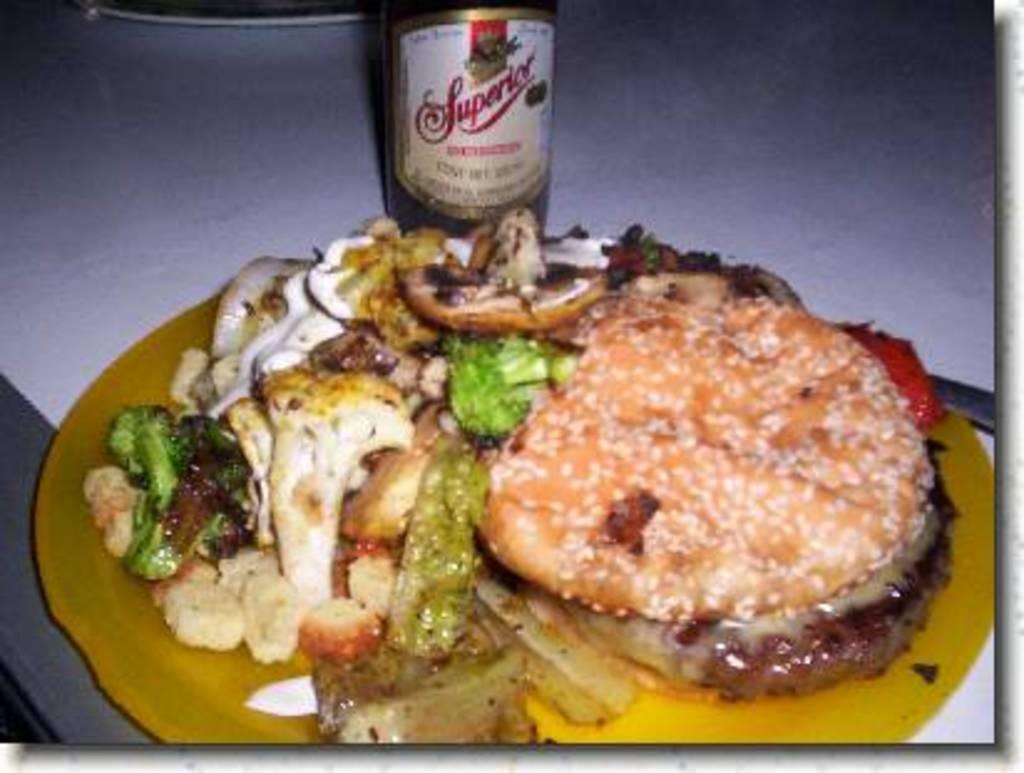Could you give a brief overview of what you see in this image? In this image I can see the plate with food. The plate is in yellow color and the food is colorful. To the side I can see the bottle. These are on the white surface. 